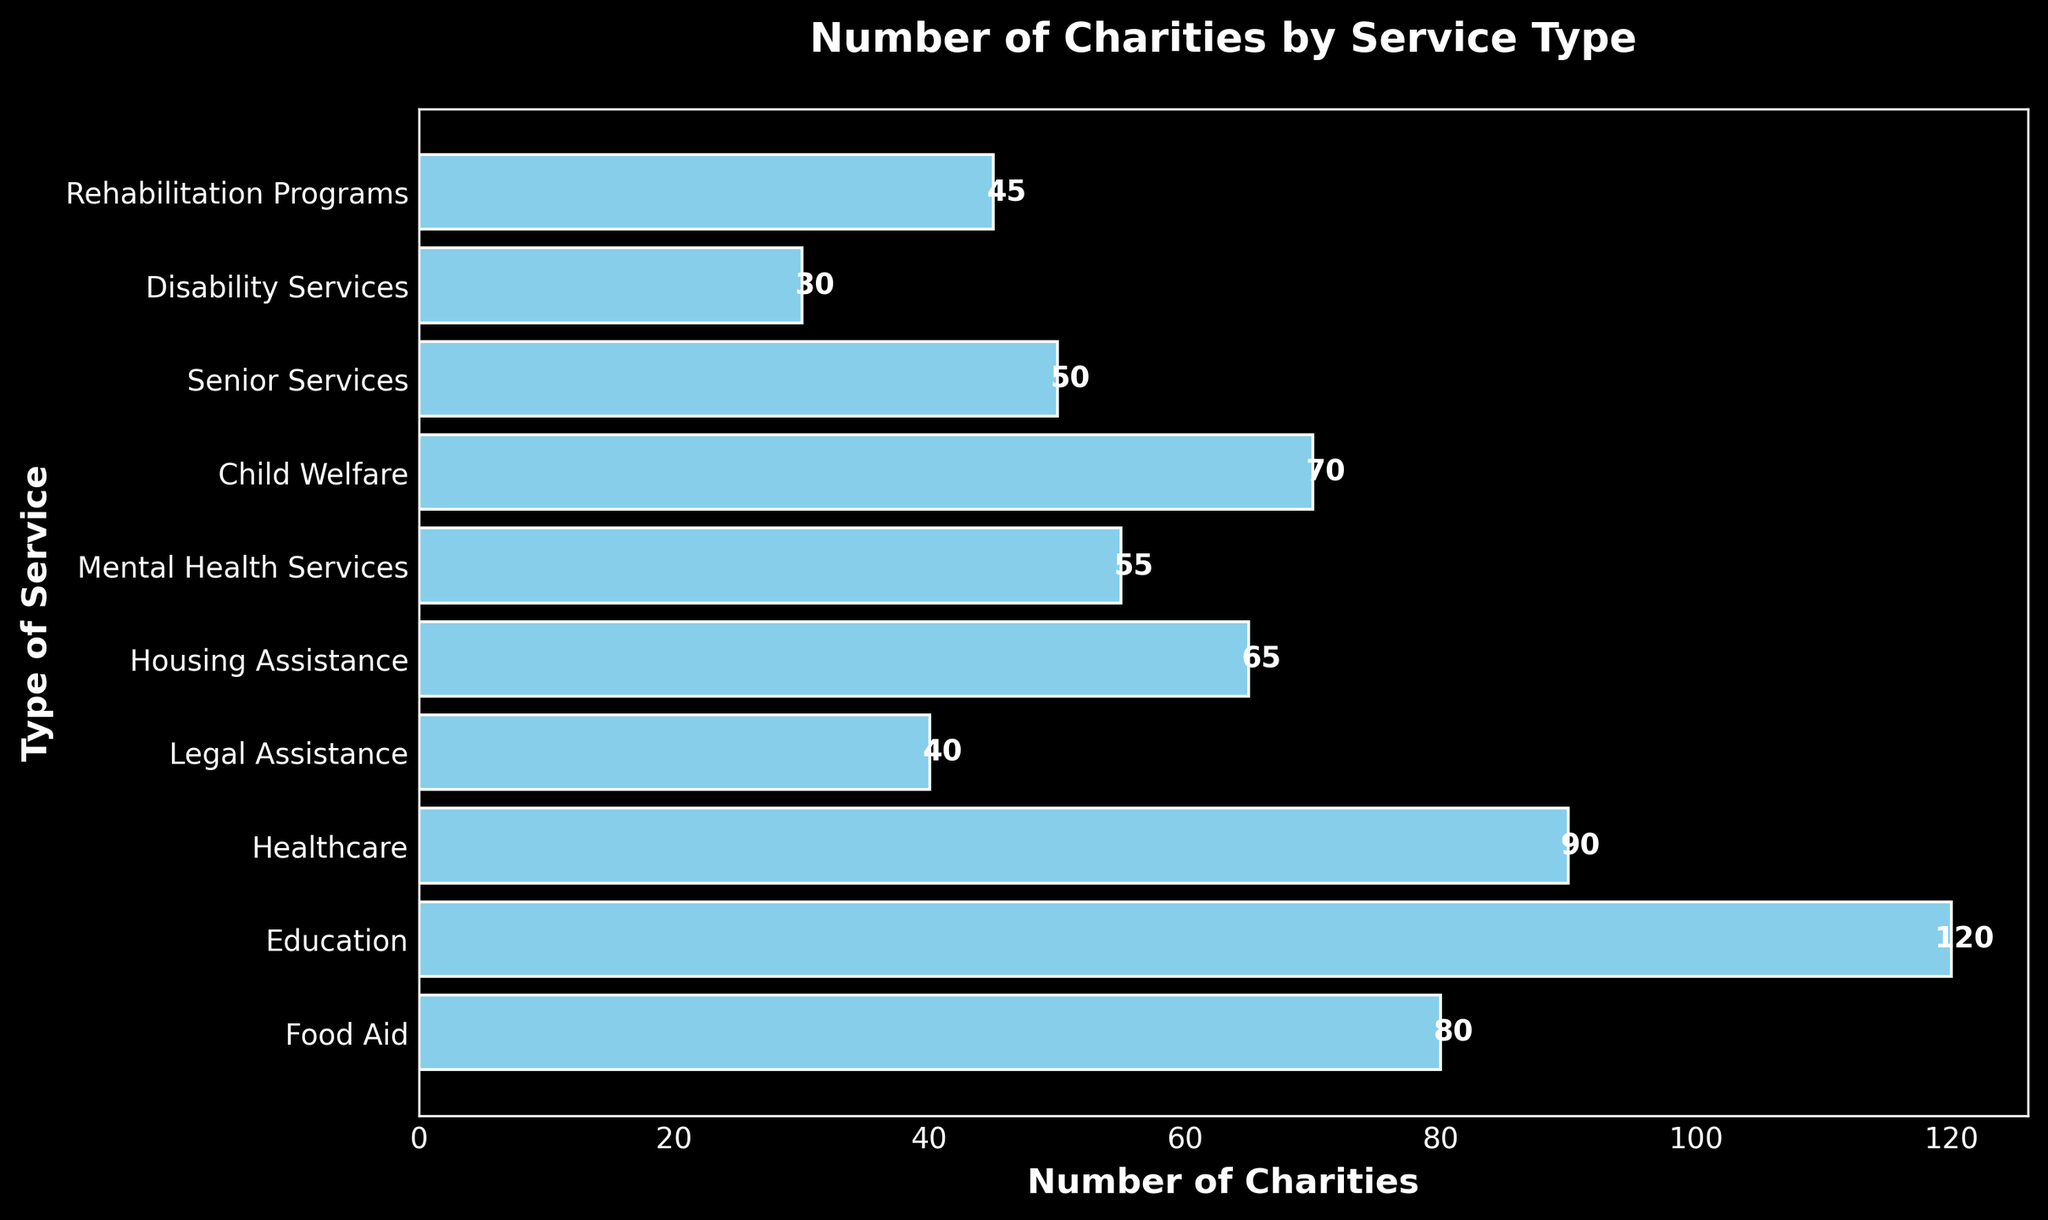What type of service has the highest number of charities? The bar for "Education" is the longest, showing the value 120.
Answer: Education Which service has fewer charities than "Healthcare" but more than "Child Welfare"? Observing the bars, "Housing Assistance" has 65 charities, which is fewer than "Healthcare" (90) and more than "Child Welfare" (70).
Answer: Housing Assistance How many more charities provide "Education" services compared to "Senior Services"? "Education" has 120 charities, and "Senior Services" has 50. The difference is 120 - 50 = 70.
Answer: 70 What is the average number of charities providing "Food Aid," "Healthcare," and "Legal Assistance"? Add the charities: 80 (Food Aid) + 90 (Healthcare) + 40 (Legal Assistance) = 210. Then divide by 3, the number of services, 210 / 3 = 70.
Answer: 70 Which service has the second-lowest number of charities? By comparing the lengths of the bars, "Disability Services" has the lowest (30) and "Rehabilitation Programs" has the next smallest (45).
Answer: Rehabilitation Programs List the services that have more than 50 charities providing them. The bars longer than "Senior Services" (50) are: "Food Aid" (80), "Education" (120), "Healthcare" (90), "Housing Assistance" (65), "Mental Health Services" (55), "Child Welfare" (70).
Answer: Food Aid, Education, Healthcare, Housing Assistance, Mental Health Services, Child Welfare By how much does the number of charities providing "Mental Health Services" exceed those providing "Rehabilitation Programs"? "Mental Health Services" has 55 charities, and "Rehabilitation Programs" has 45. The difference is 55 - 45 = 10.
Answer: 10 What is the total number of charities shown in the chart? Sum the number of charities: 80 (Food Aid) + 120 (Education) + 90 (Healthcare) + 40 (Legal Assistance) + 65 (Housing Assistance) + 55 (Mental Health Services) + 70 (Child Welfare) + 50 (Senior Services) + 30 (Disability Services) + 45 (Rehabilitation Programs) = 645.
Answer: 645 